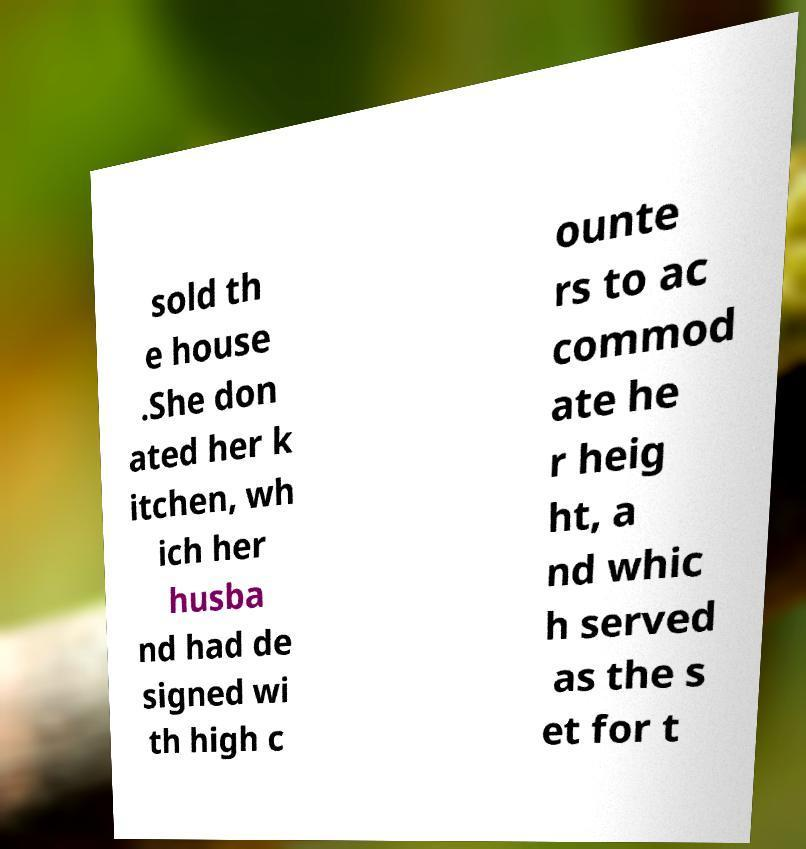Please identify and transcribe the text found in this image. sold th e house .She don ated her k itchen, wh ich her husba nd had de signed wi th high c ounte rs to ac commod ate he r heig ht, a nd whic h served as the s et for t 